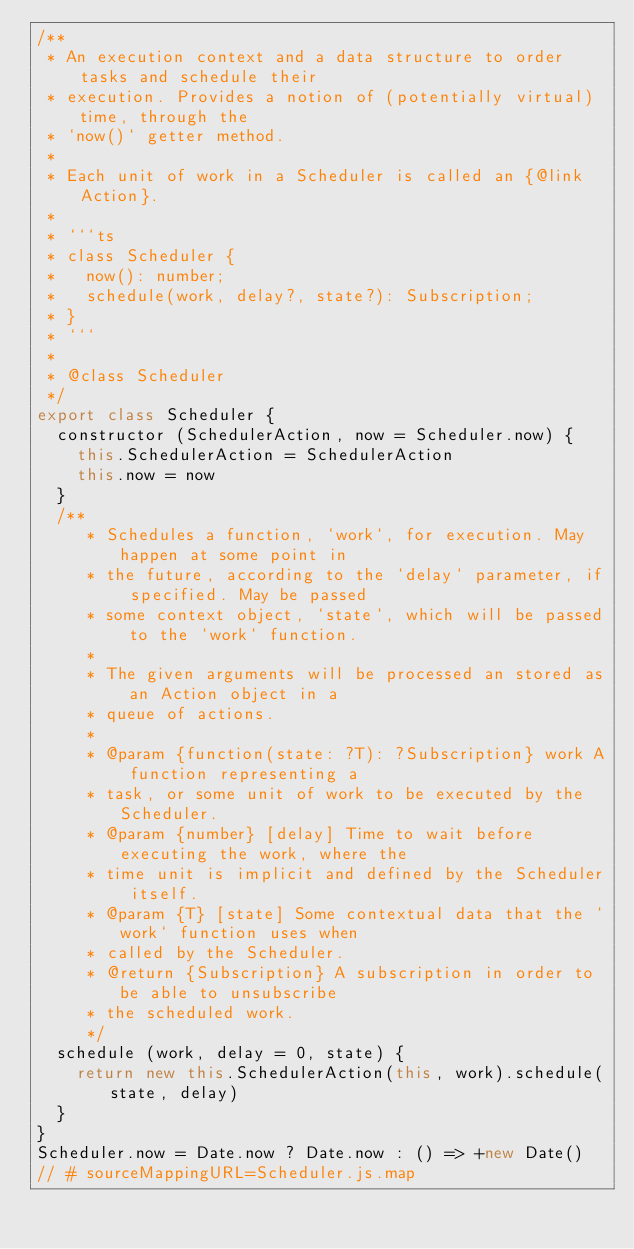Convert code to text. <code><loc_0><loc_0><loc_500><loc_500><_JavaScript_>/**
 * An execution context and a data structure to order tasks and schedule their
 * execution. Provides a notion of (potentially virtual) time, through the
 * `now()` getter method.
 *
 * Each unit of work in a Scheduler is called an {@link Action}.
 *
 * ```ts
 * class Scheduler {
 *   now(): number;
 *   schedule(work, delay?, state?): Subscription;
 * }
 * ```
 *
 * @class Scheduler
 */
export class Scheduler {
  constructor (SchedulerAction, now = Scheduler.now) {
    this.SchedulerAction = SchedulerAction
    this.now = now
  }
  /**
     * Schedules a function, `work`, for execution. May happen at some point in
     * the future, according to the `delay` parameter, if specified. May be passed
     * some context object, `state`, which will be passed to the `work` function.
     *
     * The given arguments will be processed an stored as an Action object in a
     * queue of actions.
     *
     * @param {function(state: ?T): ?Subscription} work A function representing a
     * task, or some unit of work to be executed by the Scheduler.
     * @param {number} [delay] Time to wait before executing the work, where the
     * time unit is implicit and defined by the Scheduler itself.
     * @param {T} [state] Some contextual data that the `work` function uses when
     * called by the Scheduler.
     * @return {Subscription} A subscription in order to be able to unsubscribe
     * the scheduled work.
     */
  schedule (work, delay = 0, state) {
    return new this.SchedulerAction(this, work).schedule(state, delay)
  }
}
Scheduler.now = Date.now ? Date.now : () => +new Date()
// # sourceMappingURL=Scheduler.js.map
</code> 